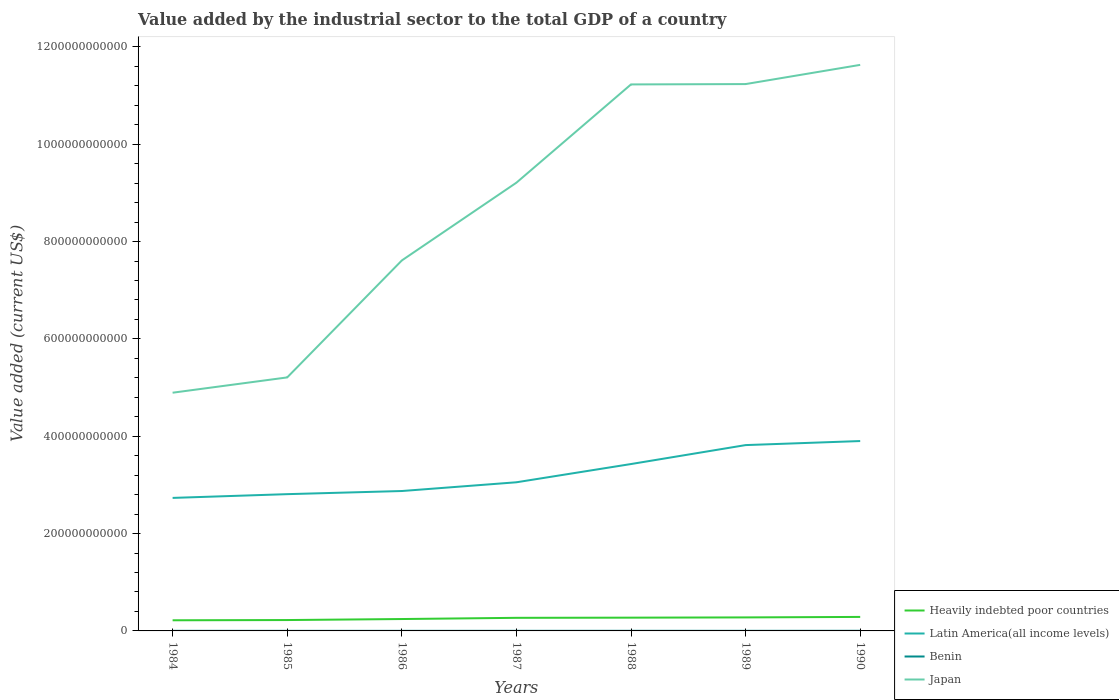Across all years, what is the maximum value added by the industrial sector to the total GDP in Benin?
Make the answer very short. 1.62e+08. What is the total value added by the industrial sector to the total GDP in Latin America(all income levels) in the graph?
Offer a terse response. -3.89e+1. What is the difference between the highest and the second highest value added by the industrial sector to the total GDP in Benin?
Offer a very short reply. 8.23e+07. What is the difference between the highest and the lowest value added by the industrial sector to the total GDP in Benin?
Make the answer very short. 2. Is the value added by the industrial sector to the total GDP in Benin strictly greater than the value added by the industrial sector to the total GDP in Latin America(all income levels) over the years?
Give a very brief answer. Yes. How many years are there in the graph?
Offer a very short reply. 7. What is the difference between two consecutive major ticks on the Y-axis?
Make the answer very short. 2.00e+11. Where does the legend appear in the graph?
Offer a very short reply. Bottom right. How many legend labels are there?
Ensure brevity in your answer.  4. What is the title of the graph?
Ensure brevity in your answer.  Value added by the industrial sector to the total GDP of a country. What is the label or title of the Y-axis?
Provide a succinct answer. Value added (current US$). What is the Value added (current US$) of Heavily indebted poor countries in 1984?
Offer a terse response. 2.19e+1. What is the Value added (current US$) of Latin America(all income levels) in 1984?
Keep it short and to the point. 2.73e+11. What is the Value added (current US$) of Benin in 1984?
Provide a succinct answer. 1.79e+08. What is the Value added (current US$) in Japan in 1984?
Ensure brevity in your answer.  4.89e+11. What is the Value added (current US$) in Heavily indebted poor countries in 1985?
Your answer should be very brief. 2.23e+1. What is the Value added (current US$) in Latin America(all income levels) in 1985?
Keep it short and to the point. 2.81e+11. What is the Value added (current US$) of Benin in 1985?
Keep it short and to the point. 1.75e+08. What is the Value added (current US$) of Japan in 1985?
Make the answer very short. 5.21e+11. What is the Value added (current US$) of Heavily indebted poor countries in 1986?
Ensure brevity in your answer.  2.44e+1. What is the Value added (current US$) in Latin America(all income levels) in 1986?
Provide a short and direct response. 2.87e+11. What is the Value added (current US$) of Benin in 1986?
Your answer should be very brief. 1.62e+08. What is the Value added (current US$) of Japan in 1986?
Offer a very short reply. 7.61e+11. What is the Value added (current US$) in Heavily indebted poor countries in 1987?
Ensure brevity in your answer.  2.69e+1. What is the Value added (current US$) in Latin America(all income levels) in 1987?
Provide a succinct answer. 3.05e+11. What is the Value added (current US$) in Benin in 1987?
Your answer should be compact. 1.93e+08. What is the Value added (current US$) of Japan in 1987?
Offer a very short reply. 9.21e+11. What is the Value added (current US$) in Heavily indebted poor countries in 1988?
Provide a short and direct response. 2.73e+1. What is the Value added (current US$) in Latin America(all income levels) in 1988?
Provide a succinct answer. 3.43e+11. What is the Value added (current US$) in Benin in 1988?
Offer a terse response. 2.17e+08. What is the Value added (current US$) of Japan in 1988?
Provide a short and direct response. 1.12e+12. What is the Value added (current US$) of Heavily indebted poor countries in 1989?
Offer a very short reply. 2.78e+1. What is the Value added (current US$) in Latin America(all income levels) in 1989?
Provide a succinct answer. 3.82e+11. What is the Value added (current US$) in Benin in 1989?
Give a very brief answer. 1.92e+08. What is the Value added (current US$) of Japan in 1989?
Provide a succinct answer. 1.12e+12. What is the Value added (current US$) in Heavily indebted poor countries in 1990?
Your answer should be compact. 2.88e+1. What is the Value added (current US$) in Latin America(all income levels) in 1990?
Give a very brief answer. 3.90e+11. What is the Value added (current US$) of Benin in 1990?
Keep it short and to the point. 2.44e+08. What is the Value added (current US$) of Japan in 1990?
Provide a short and direct response. 1.16e+12. Across all years, what is the maximum Value added (current US$) in Heavily indebted poor countries?
Ensure brevity in your answer.  2.88e+1. Across all years, what is the maximum Value added (current US$) in Latin America(all income levels)?
Make the answer very short. 3.90e+11. Across all years, what is the maximum Value added (current US$) in Benin?
Keep it short and to the point. 2.44e+08. Across all years, what is the maximum Value added (current US$) in Japan?
Ensure brevity in your answer.  1.16e+12. Across all years, what is the minimum Value added (current US$) in Heavily indebted poor countries?
Your answer should be very brief. 2.19e+1. Across all years, what is the minimum Value added (current US$) of Latin America(all income levels)?
Provide a succinct answer. 2.73e+11. Across all years, what is the minimum Value added (current US$) in Benin?
Give a very brief answer. 1.62e+08. Across all years, what is the minimum Value added (current US$) of Japan?
Provide a short and direct response. 4.89e+11. What is the total Value added (current US$) in Heavily indebted poor countries in the graph?
Offer a terse response. 1.79e+11. What is the total Value added (current US$) of Latin America(all income levels) in the graph?
Your response must be concise. 2.26e+12. What is the total Value added (current US$) in Benin in the graph?
Provide a short and direct response. 1.36e+09. What is the total Value added (current US$) in Japan in the graph?
Ensure brevity in your answer.  6.10e+12. What is the difference between the Value added (current US$) in Heavily indebted poor countries in 1984 and that in 1985?
Ensure brevity in your answer.  -4.72e+08. What is the difference between the Value added (current US$) of Latin America(all income levels) in 1984 and that in 1985?
Make the answer very short. -7.70e+09. What is the difference between the Value added (current US$) in Benin in 1984 and that in 1985?
Make the answer very short. 4.76e+06. What is the difference between the Value added (current US$) of Japan in 1984 and that in 1985?
Provide a succinct answer. -3.14e+1. What is the difference between the Value added (current US$) in Heavily indebted poor countries in 1984 and that in 1986?
Provide a short and direct response. -2.55e+09. What is the difference between the Value added (current US$) of Latin America(all income levels) in 1984 and that in 1986?
Keep it short and to the point. -1.41e+1. What is the difference between the Value added (current US$) in Benin in 1984 and that in 1986?
Ensure brevity in your answer.  1.76e+07. What is the difference between the Value added (current US$) of Japan in 1984 and that in 1986?
Offer a very short reply. -2.72e+11. What is the difference between the Value added (current US$) in Heavily indebted poor countries in 1984 and that in 1987?
Give a very brief answer. -5.03e+09. What is the difference between the Value added (current US$) of Latin America(all income levels) in 1984 and that in 1987?
Offer a terse response. -3.21e+1. What is the difference between the Value added (current US$) in Benin in 1984 and that in 1987?
Ensure brevity in your answer.  -1.38e+07. What is the difference between the Value added (current US$) of Japan in 1984 and that in 1987?
Provide a short and direct response. -4.32e+11. What is the difference between the Value added (current US$) of Heavily indebted poor countries in 1984 and that in 1988?
Give a very brief answer. -5.39e+09. What is the difference between the Value added (current US$) of Latin America(all income levels) in 1984 and that in 1988?
Your answer should be compact. -6.96e+1. What is the difference between the Value added (current US$) of Benin in 1984 and that in 1988?
Make the answer very short. -3.76e+07. What is the difference between the Value added (current US$) of Japan in 1984 and that in 1988?
Ensure brevity in your answer.  -6.33e+11. What is the difference between the Value added (current US$) in Heavily indebted poor countries in 1984 and that in 1989?
Provide a succinct answer. -5.90e+09. What is the difference between the Value added (current US$) in Latin America(all income levels) in 1984 and that in 1989?
Give a very brief answer. -1.09e+11. What is the difference between the Value added (current US$) in Benin in 1984 and that in 1989?
Provide a succinct answer. -1.24e+07. What is the difference between the Value added (current US$) in Japan in 1984 and that in 1989?
Your answer should be very brief. -6.34e+11. What is the difference between the Value added (current US$) of Heavily indebted poor countries in 1984 and that in 1990?
Give a very brief answer. -6.90e+09. What is the difference between the Value added (current US$) of Latin America(all income levels) in 1984 and that in 1990?
Ensure brevity in your answer.  -1.17e+11. What is the difference between the Value added (current US$) in Benin in 1984 and that in 1990?
Keep it short and to the point. -6.47e+07. What is the difference between the Value added (current US$) of Japan in 1984 and that in 1990?
Offer a very short reply. -6.74e+11. What is the difference between the Value added (current US$) in Heavily indebted poor countries in 1985 and that in 1986?
Provide a succinct answer. -2.07e+09. What is the difference between the Value added (current US$) of Latin America(all income levels) in 1985 and that in 1986?
Your answer should be compact. -6.44e+09. What is the difference between the Value added (current US$) in Benin in 1985 and that in 1986?
Your response must be concise. 1.29e+07. What is the difference between the Value added (current US$) in Japan in 1985 and that in 1986?
Keep it short and to the point. -2.40e+11. What is the difference between the Value added (current US$) in Heavily indebted poor countries in 1985 and that in 1987?
Give a very brief answer. -4.55e+09. What is the difference between the Value added (current US$) of Latin America(all income levels) in 1985 and that in 1987?
Your answer should be very brief. -2.44e+1. What is the difference between the Value added (current US$) in Benin in 1985 and that in 1987?
Give a very brief answer. -1.85e+07. What is the difference between the Value added (current US$) in Japan in 1985 and that in 1987?
Your answer should be compact. -4.00e+11. What is the difference between the Value added (current US$) of Heavily indebted poor countries in 1985 and that in 1988?
Offer a terse response. -4.91e+09. What is the difference between the Value added (current US$) in Latin America(all income levels) in 1985 and that in 1988?
Your response must be concise. -6.19e+1. What is the difference between the Value added (current US$) of Benin in 1985 and that in 1988?
Make the answer very short. -4.24e+07. What is the difference between the Value added (current US$) of Japan in 1985 and that in 1988?
Provide a short and direct response. -6.02e+11. What is the difference between the Value added (current US$) of Heavily indebted poor countries in 1985 and that in 1989?
Your answer should be compact. -5.43e+09. What is the difference between the Value added (current US$) in Latin America(all income levels) in 1985 and that in 1989?
Your answer should be compact. -1.01e+11. What is the difference between the Value added (current US$) of Benin in 1985 and that in 1989?
Provide a short and direct response. -1.72e+07. What is the difference between the Value added (current US$) in Japan in 1985 and that in 1989?
Your answer should be compact. -6.03e+11. What is the difference between the Value added (current US$) in Heavily indebted poor countries in 1985 and that in 1990?
Provide a short and direct response. -6.43e+09. What is the difference between the Value added (current US$) in Latin America(all income levels) in 1985 and that in 1990?
Give a very brief answer. -1.09e+11. What is the difference between the Value added (current US$) in Benin in 1985 and that in 1990?
Your answer should be very brief. -6.94e+07. What is the difference between the Value added (current US$) in Japan in 1985 and that in 1990?
Keep it short and to the point. -6.42e+11. What is the difference between the Value added (current US$) of Heavily indebted poor countries in 1986 and that in 1987?
Give a very brief answer. -2.48e+09. What is the difference between the Value added (current US$) of Latin America(all income levels) in 1986 and that in 1987?
Ensure brevity in your answer.  -1.80e+1. What is the difference between the Value added (current US$) in Benin in 1986 and that in 1987?
Give a very brief answer. -3.14e+07. What is the difference between the Value added (current US$) in Japan in 1986 and that in 1987?
Offer a very short reply. -1.60e+11. What is the difference between the Value added (current US$) of Heavily indebted poor countries in 1986 and that in 1988?
Provide a short and direct response. -2.84e+09. What is the difference between the Value added (current US$) in Latin America(all income levels) in 1986 and that in 1988?
Give a very brief answer. -5.54e+1. What is the difference between the Value added (current US$) of Benin in 1986 and that in 1988?
Provide a succinct answer. -5.53e+07. What is the difference between the Value added (current US$) in Japan in 1986 and that in 1988?
Keep it short and to the point. -3.62e+11. What is the difference between the Value added (current US$) of Heavily indebted poor countries in 1986 and that in 1989?
Offer a terse response. -3.35e+09. What is the difference between the Value added (current US$) in Latin America(all income levels) in 1986 and that in 1989?
Your answer should be compact. -9.44e+1. What is the difference between the Value added (current US$) of Benin in 1986 and that in 1989?
Keep it short and to the point. -3.00e+07. What is the difference between the Value added (current US$) of Japan in 1986 and that in 1989?
Keep it short and to the point. -3.62e+11. What is the difference between the Value added (current US$) in Heavily indebted poor countries in 1986 and that in 1990?
Your answer should be very brief. -4.36e+09. What is the difference between the Value added (current US$) of Latin America(all income levels) in 1986 and that in 1990?
Your answer should be very brief. -1.03e+11. What is the difference between the Value added (current US$) of Benin in 1986 and that in 1990?
Provide a succinct answer. -8.23e+07. What is the difference between the Value added (current US$) in Japan in 1986 and that in 1990?
Give a very brief answer. -4.02e+11. What is the difference between the Value added (current US$) in Heavily indebted poor countries in 1987 and that in 1988?
Provide a succinct answer. -3.60e+08. What is the difference between the Value added (current US$) in Latin America(all income levels) in 1987 and that in 1988?
Offer a terse response. -3.75e+1. What is the difference between the Value added (current US$) of Benin in 1987 and that in 1988?
Your response must be concise. -2.38e+07. What is the difference between the Value added (current US$) of Japan in 1987 and that in 1988?
Your response must be concise. -2.02e+11. What is the difference between the Value added (current US$) in Heavily indebted poor countries in 1987 and that in 1989?
Ensure brevity in your answer.  -8.71e+08. What is the difference between the Value added (current US$) of Latin America(all income levels) in 1987 and that in 1989?
Provide a succinct answer. -7.64e+1. What is the difference between the Value added (current US$) in Benin in 1987 and that in 1989?
Your response must be concise. 1.39e+06. What is the difference between the Value added (current US$) in Japan in 1987 and that in 1989?
Your answer should be compact. -2.03e+11. What is the difference between the Value added (current US$) of Heavily indebted poor countries in 1987 and that in 1990?
Give a very brief answer. -1.88e+09. What is the difference between the Value added (current US$) of Latin America(all income levels) in 1987 and that in 1990?
Your answer should be compact. -8.47e+1. What is the difference between the Value added (current US$) of Benin in 1987 and that in 1990?
Provide a short and direct response. -5.09e+07. What is the difference between the Value added (current US$) of Japan in 1987 and that in 1990?
Provide a succinct answer. -2.42e+11. What is the difference between the Value added (current US$) of Heavily indebted poor countries in 1988 and that in 1989?
Your answer should be very brief. -5.11e+08. What is the difference between the Value added (current US$) of Latin America(all income levels) in 1988 and that in 1989?
Provide a succinct answer. -3.89e+1. What is the difference between the Value added (current US$) of Benin in 1988 and that in 1989?
Offer a terse response. 2.52e+07. What is the difference between the Value added (current US$) of Japan in 1988 and that in 1989?
Your answer should be very brief. -6.85e+08. What is the difference between the Value added (current US$) of Heavily indebted poor countries in 1988 and that in 1990?
Your answer should be compact. -1.52e+09. What is the difference between the Value added (current US$) of Latin America(all income levels) in 1988 and that in 1990?
Keep it short and to the point. -4.73e+1. What is the difference between the Value added (current US$) of Benin in 1988 and that in 1990?
Ensure brevity in your answer.  -2.71e+07. What is the difference between the Value added (current US$) of Japan in 1988 and that in 1990?
Provide a succinct answer. -4.02e+1. What is the difference between the Value added (current US$) in Heavily indebted poor countries in 1989 and that in 1990?
Your answer should be compact. -1.01e+09. What is the difference between the Value added (current US$) of Latin America(all income levels) in 1989 and that in 1990?
Make the answer very short. -8.32e+09. What is the difference between the Value added (current US$) of Benin in 1989 and that in 1990?
Give a very brief answer. -5.23e+07. What is the difference between the Value added (current US$) of Japan in 1989 and that in 1990?
Offer a terse response. -3.95e+1. What is the difference between the Value added (current US$) in Heavily indebted poor countries in 1984 and the Value added (current US$) in Latin America(all income levels) in 1985?
Keep it short and to the point. -2.59e+11. What is the difference between the Value added (current US$) in Heavily indebted poor countries in 1984 and the Value added (current US$) in Benin in 1985?
Your answer should be very brief. 2.17e+1. What is the difference between the Value added (current US$) in Heavily indebted poor countries in 1984 and the Value added (current US$) in Japan in 1985?
Offer a terse response. -4.99e+11. What is the difference between the Value added (current US$) in Latin America(all income levels) in 1984 and the Value added (current US$) in Benin in 1985?
Give a very brief answer. 2.73e+11. What is the difference between the Value added (current US$) of Latin America(all income levels) in 1984 and the Value added (current US$) of Japan in 1985?
Provide a succinct answer. -2.48e+11. What is the difference between the Value added (current US$) of Benin in 1984 and the Value added (current US$) of Japan in 1985?
Your answer should be compact. -5.21e+11. What is the difference between the Value added (current US$) in Heavily indebted poor countries in 1984 and the Value added (current US$) in Latin America(all income levels) in 1986?
Offer a terse response. -2.66e+11. What is the difference between the Value added (current US$) in Heavily indebted poor countries in 1984 and the Value added (current US$) in Benin in 1986?
Your response must be concise. 2.17e+1. What is the difference between the Value added (current US$) in Heavily indebted poor countries in 1984 and the Value added (current US$) in Japan in 1986?
Provide a short and direct response. -7.39e+11. What is the difference between the Value added (current US$) in Latin America(all income levels) in 1984 and the Value added (current US$) in Benin in 1986?
Give a very brief answer. 2.73e+11. What is the difference between the Value added (current US$) of Latin America(all income levels) in 1984 and the Value added (current US$) of Japan in 1986?
Provide a succinct answer. -4.88e+11. What is the difference between the Value added (current US$) in Benin in 1984 and the Value added (current US$) in Japan in 1986?
Offer a very short reply. -7.61e+11. What is the difference between the Value added (current US$) of Heavily indebted poor countries in 1984 and the Value added (current US$) of Latin America(all income levels) in 1987?
Offer a very short reply. -2.84e+11. What is the difference between the Value added (current US$) in Heavily indebted poor countries in 1984 and the Value added (current US$) in Benin in 1987?
Your answer should be compact. 2.17e+1. What is the difference between the Value added (current US$) in Heavily indebted poor countries in 1984 and the Value added (current US$) in Japan in 1987?
Offer a terse response. -8.99e+11. What is the difference between the Value added (current US$) in Latin America(all income levels) in 1984 and the Value added (current US$) in Benin in 1987?
Provide a short and direct response. 2.73e+11. What is the difference between the Value added (current US$) of Latin America(all income levels) in 1984 and the Value added (current US$) of Japan in 1987?
Make the answer very short. -6.48e+11. What is the difference between the Value added (current US$) in Benin in 1984 and the Value added (current US$) in Japan in 1987?
Your response must be concise. -9.21e+11. What is the difference between the Value added (current US$) in Heavily indebted poor countries in 1984 and the Value added (current US$) in Latin America(all income levels) in 1988?
Provide a succinct answer. -3.21e+11. What is the difference between the Value added (current US$) in Heavily indebted poor countries in 1984 and the Value added (current US$) in Benin in 1988?
Your response must be concise. 2.17e+1. What is the difference between the Value added (current US$) in Heavily indebted poor countries in 1984 and the Value added (current US$) in Japan in 1988?
Keep it short and to the point. -1.10e+12. What is the difference between the Value added (current US$) of Latin America(all income levels) in 1984 and the Value added (current US$) of Benin in 1988?
Ensure brevity in your answer.  2.73e+11. What is the difference between the Value added (current US$) of Latin America(all income levels) in 1984 and the Value added (current US$) of Japan in 1988?
Your response must be concise. -8.50e+11. What is the difference between the Value added (current US$) of Benin in 1984 and the Value added (current US$) of Japan in 1988?
Your response must be concise. -1.12e+12. What is the difference between the Value added (current US$) in Heavily indebted poor countries in 1984 and the Value added (current US$) in Latin America(all income levels) in 1989?
Offer a terse response. -3.60e+11. What is the difference between the Value added (current US$) of Heavily indebted poor countries in 1984 and the Value added (current US$) of Benin in 1989?
Ensure brevity in your answer.  2.17e+1. What is the difference between the Value added (current US$) of Heavily indebted poor countries in 1984 and the Value added (current US$) of Japan in 1989?
Your answer should be very brief. -1.10e+12. What is the difference between the Value added (current US$) of Latin America(all income levels) in 1984 and the Value added (current US$) of Benin in 1989?
Keep it short and to the point. 2.73e+11. What is the difference between the Value added (current US$) in Latin America(all income levels) in 1984 and the Value added (current US$) in Japan in 1989?
Your answer should be compact. -8.50e+11. What is the difference between the Value added (current US$) in Benin in 1984 and the Value added (current US$) in Japan in 1989?
Make the answer very short. -1.12e+12. What is the difference between the Value added (current US$) in Heavily indebted poor countries in 1984 and the Value added (current US$) in Latin America(all income levels) in 1990?
Ensure brevity in your answer.  -3.68e+11. What is the difference between the Value added (current US$) of Heavily indebted poor countries in 1984 and the Value added (current US$) of Benin in 1990?
Your response must be concise. 2.16e+1. What is the difference between the Value added (current US$) of Heavily indebted poor countries in 1984 and the Value added (current US$) of Japan in 1990?
Provide a short and direct response. -1.14e+12. What is the difference between the Value added (current US$) of Latin America(all income levels) in 1984 and the Value added (current US$) of Benin in 1990?
Your answer should be compact. 2.73e+11. What is the difference between the Value added (current US$) of Latin America(all income levels) in 1984 and the Value added (current US$) of Japan in 1990?
Provide a short and direct response. -8.90e+11. What is the difference between the Value added (current US$) of Benin in 1984 and the Value added (current US$) of Japan in 1990?
Offer a very short reply. -1.16e+12. What is the difference between the Value added (current US$) of Heavily indebted poor countries in 1985 and the Value added (current US$) of Latin America(all income levels) in 1986?
Your answer should be compact. -2.65e+11. What is the difference between the Value added (current US$) of Heavily indebted poor countries in 1985 and the Value added (current US$) of Benin in 1986?
Offer a terse response. 2.22e+1. What is the difference between the Value added (current US$) of Heavily indebted poor countries in 1985 and the Value added (current US$) of Japan in 1986?
Give a very brief answer. -7.39e+11. What is the difference between the Value added (current US$) of Latin America(all income levels) in 1985 and the Value added (current US$) of Benin in 1986?
Offer a terse response. 2.81e+11. What is the difference between the Value added (current US$) of Latin America(all income levels) in 1985 and the Value added (current US$) of Japan in 1986?
Your answer should be compact. -4.80e+11. What is the difference between the Value added (current US$) in Benin in 1985 and the Value added (current US$) in Japan in 1986?
Provide a short and direct response. -7.61e+11. What is the difference between the Value added (current US$) of Heavily indebted poor countries in 1985 and the Value added (current US$) of Latin America(all income levels) in 1987?
Make the answer very short. -2.83e+11. What is the difference between the Value added (current US$) in Heavily indebted poor countries in 1985 and the Value added (current US$) in Benin in 1987?
Provide a succinct answer. 2.22e+1. What is the difference between the Value added (current US$) of Heavily indebted poor countries in 1985 and the Value added (current US$) of Japan in 1987?
Your response must be concise. -8.99e+11. What is the difference between the Value added (current US$) of Latin America(all income levels) in 1985 and the Value added (current US$) of Benin in 1987?
Your answer should be compact. 2.81e+11. What is the difference between the Value added (current US$) in Latin America(all income levels) in 1985 and the Value added (current US$) in Japan in 1987?
Keep it short and to the point. -6.40e+11. What is the difference between the Value added (current US$) in Benin in 1985 and the Value added (current US$) in Japan in 1987?
Offer a very short reply. -9.21e+11. What is the difference between the Value added (current US$) of Heavily indebted poor countries in 1985 and the Value added (current US$) of Latin America(all income levels) in 1988?
Ensure brevity in your answer.  -3.21e+11. What is the difference between the Value added (current US$) of Heavily indebted poor countries in 1985 and the Value added (current US$) of Benin in 1988?
Keep it short and to the point. 2.21e+1. What is the difference between the Value added (current US$) of Heavily indebted poor countries in 1985 and the Value added (current US$) of Japan in 1988?
Provide a short and direct response. -1.10e+12. What is the difference between the Value added (current US$) in Latin America(all income levels) in 1985 and the Value added (current US$) in Benin in 1988?
Provide a short and direct response. 2.81e+11. What is the difference between the Value added (current US$) in Latin America(all income levels) in 1985 and the Value added (current US$) in Japan in 1988?
Provide a short and direct response. -8.42e+11. What is the difference between the Value added (current US$) of Benin in 1985 and the Value added (current US$) of Japan in 1988?
Your answer should be compact. -1.12e+12. What is the difference between the Value added (current US$) of Heavily indebted poor countries in 1985 and the Value added (current US$) of Latin America(all income levels) in 1989?
Give a very brief answer. -3.59e+11. What is the difference between the Value added (current US$) of Heavily indebted poor countries in 1985 and the Value added (current US$) of Benin in 1989?
Make the answer very short. 2.22e+1. What is the difference between the Value added (current US$) in Heavily indebted poor countries in 1985 and the Value added (current US$) in Japan in 1989?
Ensure brevity in your answer.  -1.10e+12. What is the difference between the Value added (current US$) in Latin America(all income levels) in 1985 and the Value added (current US$) in Benin in 1989?
Keep it short and to the point. 2.81e+11. What is the difference between the Value added (current US$) of Latin America(all income levels) in 1985 and the Value added (current US$) of Japan in 1989?
Make the answer very short. -8.43e+11. What is the difference between the Value added (current US$) in Benin in 1985 and the Value added (current US$) in Japan in 1989?
Provide a succinct answer. -1.12e+12. What is the difference between the Value added (current US$) in Heavily indebted poor countries in 1985 and the Value added (current US$) in Latin America(all income levels) in 1990?
Provide a succinct answer. -3.68e+11. What is the difference between the Value added (current US$) of Heavily indebted poor countries in 1985 and the Value added (current US$) of Benin in 1990?
Keep it short and to the point. 2.21e+1. What is the difference between the Value added (current US$) of Heavily indebted poor countries in 1985 and the Value added (current US$) of Japan in 1990?
Keep it short and to the point. -1.14e+12. What is the difference between the Value added (current US$) of Latin America(all income levels) in 1985 and the Value added (current US$) of Benin in 1990?
Provide a short and direct response. 2.81e+11. What is the difference between the Value added (current US$) of Latin America(all income levels) in 1985 and the Value added (current US$) of Japan in 1990?
Your answer should be compact. -8.82e+11. What is the difference between the Value added (current US$) of Benin in 1985 and the Value added (current US$) of Japan in 1990?
Your response must be concise. -1.16e+12. What is the difference between the Value added (current US$) of Heavily indebted poor countries in 1986 and the Value added (current US$) of Latin America(all income levels) in 1987?
Give a very brief answer. -2.81e+11. What is the difference between the Value added (current US$) of Heavily indebted poor countries in 1986 and the Value added (current US$) of Benin in 1987?
Your answer should be compact. 2.42e+1. What is the difference between the Value added (current US$) of Heavily indebted poor countries in 1986 and the Value added (current US$) of Japan in 1987?
Provide a succinct answer. -8.97e+11. What is the difference between the Value added (current US$) of Latin America(all income levels) in 1986 and the Value added (current US$) of Benin in 1987?
Make the answer very short. 2.87e+11. What is the difference between the Value added (current US$) in Latin America(all income levels) in 1986 and the Value added (current US$) in Japan in 1987?
Your answer should be very brief. -6.34e+11. What is the difference between the Value added (current US$) in Benin in 1986 and the Value added (current US$) in Japan in 1987?
Offer a very short reply. -9.21e+11. What is the difference between the Value added (current US$) in Heavily indebted poor countries in 1986 and the Value added (current US$) in Latin America(all income levels) in 1988?
Keep it short and to the point. -3.18e+11. What is the difference between the Value added (current US$) in Heavily indebted poor countries in 1986 and the Value added (current US$) in Benin in 1988?
Your response must be concise. 2.42e+1. What is the difference between the Value added (current US$) of Heavily indebted poor countries in 1986 and the Value added (current US$) of Japan in 1988?
Keep it short and to the point. -1.10e+12. What is the difference between the Value added (current US$) in Latin America(all income levels) in 1986 and the Value added (current US$) in Benin in 1988?
Provide a short and direct response. 2.87e+11. What is the difference between the Value added (current US$) in Latin America(all income levels) in 1986 and the Value added (current US$) in Japan in 1988?
Offer a terse response. -8.35e+11. What is the difference between the Value added (current US$) in Benin in 1986 and the Value added (current US$) in Japan in 1988?
Make the answer very short. -1.12e+12. What is the difference between the Value added (current US$) of Heavily indebted poor countries in 1986 and the Value added (current US$) of Latin America(all income levels) in 1989?
Offer a terse response. -3.57e+11. What is the difference between the Value added (current US$) in Heavily indebted poor countries in 1986 and the Value added (current US$) in Benin in 1989?
Make the answer very short. 2.42e+1. What is the difference between the Value added (current US$) in Heavily indebted poor countries in 1986 and the Value added (current US$) in Japan in 1989?
Ensure brevity in your answer.  -1.10e+12. What is the difference between the Value added (current US$) of Latin America(all income levels) in 1986 and the Value added (current US$) of Benin in 1989?
Offer a terse response. 2.87e+11. What is the difference between the Value added (current US$) of Latin America(all income levels) in 1986 and the Value added (current US$) of Japan in 1989?
Keep it short and to the point. -8.36e+11. What is the difference between the Value added (current US$) in Benin in 1986 and the Value added (current US$) in Japan in 1989?
Your answer should be very brief. -1.12e+12. What is the difference between the Value added (current US$) in Heavily indebted poor countries in 1986 and the Value added (current US$) in Latin America(all income levels) in 1990?
Your answer should be compact. -3.66e+11. What is the difference between the Value added (current US$) in Heavily indebted poor countries in 1986 and the Value added (current US$) in Benin in 1990?
Give a very brief answer. 2.42e+1. What is the difference between the Value added (current US$) of Heavily indebted poor countries in 1986 and the Value added (current US$) of Japan in 1990?
Keep it short and to the point. -1.14e+12. What is the difference between the Value added (current US$) of Latin America(all income levels) in 1986 and the Value added (current US$) of Benin in 1990?
Make the answer very short. 2.87e+11. What is the difference between the Value added (current US$) in Latin America(all income levels) in 1986 and the Value added (current US$) in Japan in 1990?
Offer a terse response. -8.76e+11. What is the difference between the Value added (current US$) in Benin in 1986 and the Value added (current US$) in Japan in 1990?
Make the answer very short. -1.16e+12. What is the difference between the Value added (current US$) of Heavily indebted poor countries in 1987 and the Value added (current US$) of Latin America(all income levels) in 1988?
Ensure brevity in your answer.  -3.16e+11. What is the difference between the Value added (current US$) of Heavily indebted poor countries in 1987 and the Value added (current US$) of Benin in 1988?
Offer a terse response. 2.67e+1. What is the difference between the Value added (current US$) in Heavily indebted poor countries in 1987 and the Value added (current US$) in Japan in 1988?
Your response must be concise. -1.10e+12. What is the difference between the Value added (current US$) of Latin America(all income levels) in 1987 and the Value added (current US$) of Benin in 1988?
Give a very brief answer. 3.05e+11. What is the difference between the Value added (current US$) in Latin America(all income levels) in 1987 and the Value added (current US$) in Japan in 1988?
Offer a terse response. -8.17e+11. What is the difference between the Value added (current US$) of Benin in 1987 and the Value added (current US$) of Japan in 1988?
Offer a terse response. -1.12e+12. What is the difference between the Value added (current US$) of Heavily indebted poor countries in 1987 and the Value added (current US$) of Latin America(all income levels) in 1989?
Make the answer very short. -3.55e+11. What is the difference between the Value added (current US$) in Heavily indebted poor countries in 1987 and the Value added (current US$) in Benin in 1989?
Your answer should be compact. 2.67e+1. What is the difference between the Value added (current US$) of Heavily indebted poor countries in 1987 and the Value added (current US$) of Japan in 1989?
Provide a short and direct response. -1.10e+12. What is the difference between the Value added (current US$) in Latin America(all income levels) in 1987 and the Value added (current US$) in Benin in 1989?
Provide a short and direct response. 3.05e+11. What is the difference between the Value added (current US$) of Latin America(all income levels) in 1987 and the Value added (current US$) of Japan in 1989?
Provide a short and direct response. -8.18e+11. What is the difference between the Value added (current US$) of Benin in 1987 and the Value added (current US$) of Japan in 1989?
Provide a short and direct response. -1.12e+12. What is the difference between the Value added (current US$) of Heavily indebted poor countries in 1987 and the Value added (current US$) of Latin America(all income levels) in 1990?
Keep it short and to the point. -3.63e+11. What is the difference between the Value added (current US$) in Heavily indebted poor countries in 1987 and the Value added (current US$) in Benin in 1990?
Your answer should be very brief. 2.67e+1. What is the difference between the Value added (current US$) in Heavily indebted poor countries in 1987 and the Value added (current US$) in Japan in 1990?
Keep it short and to the point. -1.14e+12. What is the difference between the Value added (current US$) of Latin America(all income levels) in 1987 and the Value added (current US$) of Benin in 1990?
Offer a very short reply. 3.05e+11. What is the difference between the Value added (current US$) in Latin America(all income levels) in 1987 and the Value added (current US$) in Japan in 1990?
Offer a terse response. -8.58e+11. What is the difference between the Value added (current US$) in Benin in 1987 and the Value added (current US$) in Japan in 1990?
Make the answer very short. -1.16e+12. What is the difference between the Value added (current US$) of Heavily indebted poor countries in 1988 and the Value added (current US$) of Latin America(all income levels) in 1989?
Ensure brevity in your answer.  -3.55e+11. What is the difference between the Value added (current US$) in Heavily indebted poor countries in 1988 and the Value added (current US$) in Benin in 1989?
Offer a very short reply. 2.71e+1. What is the difference between the Value added (current US$) of Heavily indebted poor countries in 1988 and the Value added (current US$) of Japan in 1989?
Give a very brief answer. -1.10e+12. What is the difference between the Value added (current US$) in Latin America(all income levels) in 1988 and the Value added (current US$) in Benin in 1989?
Provide a succinct answer. 3.43e+11. What is the difference between the Value added (current US$) in Latin America(all income levels) in 1988 and the Value added (current US$) in Japan in 1989?
Offer a very short reply. -7.81e+11. What is the difference between the Value added (current US$) in Benin in 1988 and the Value added (current US$) in Japan in 1989?
Ensure brevity in your answer.  -1.12e+12. What is the difference between the Value added (current US$) in Heavily indebted poor countries in 1988 and the Value added (current US$) in Latin America(all income levels) in 1990?
Provide a succinct answer. -3.63e+11. What is the difference between the Value added (current US$) in Heavily indebted poor countries in 1988 and the Value added (current US$) in Benin in 1990?
Make the answer very short. 2.70e+1. What is the difference between the Value added (current US$) of Heavily indebted poor countries in 1988 and the Value added (current US$) of Japan in 1990?
Offer a very short reply. -1.14e+12. What is the difference between the Value added (current US$) of Latin America(all income levels) in 1988 and the Value added (current US$) of Benin in 1990?
Ensure brevity in your answer.  3.43e+11. What is the difference between the Value added (current US$) of Latin America(all income levels) in 1988 and the Value added (current US$) of Japan in 1990?
Your response must be concise. -8.20e+11. What is the difference between the Value added (current US$) of Benin in 1988 and the Value added (current US$) of Japan in 1990?
Make the answer very short. -1.16e+12. What is the difference between the Value added (current US$) in Heavily indebted poor countries in 1989 and the Value added (current US$) in Latin America(all income levels) in 1990?
Ensure brevity in your answer.  -3.62e+11. What is the difference between the Value added (current US$) in Heavily indebted poor countries in 1989 and the Value added (current US$) in Benin in 1990?
Give a very brief answer. 2.75e+1. What is the difference between the Value added (current US$) of Heavily indebted poor countries in 1989 and the Value added (current US$) of Japan in 1990?
Keep it short and to the point. -1.14e+12. What is the difference between the Value added (current US$) of Latin America(all income levels) in 1989 and the Value added (current US$) of Benin in 1990?
Provide a short and direct response. 3.82e+11. What is the difference between the Value added (current US$) in Latin America(all income levels) in 1989 and the Value added (current US$) in Japan in 1990?
Ensure brevity in your answer.  -7.81e+11. What is the difference between the Value added (current US$) of Benin in 1989 and the Value added (current US$) of Japan in 1990?
Provide a short and direct response. -1.16e+12. What is the average Value added (current US$) of Heavily indebted poor countries per year?
Offer a very short reply. 2.56e+1. What is the average Value added (current US$) in Latin America(all income levels) per year?
Offer a terse response. 3.23e+11. What is the average Value added (current US$) of Benin per year?
Keep it short and to the point. 1.95e+08. What is the average Value added (current US$) of Japan per year?
Ensure brevity in your answer.  8.72e+11. In the year 1984, what is the difference between the Value added (current US$) in Heavily indebted poor countries and Value added (current US$) in Latin America(all income levels)?
Offer a terse response. -2.51e+11. In the year 1984, what is the difference between the Value added (current US$) of Heavily indebted poor countries and Value added (current US$) of Benin?
Keep it short and to the point. 2.17e+1. In the year 1984, what is the difference between the Value added (current US$) in Heavily indebted poor countries and Value added (current US$) in Japan?
Offer a very short reply. -4.68e+11. In the year 1984, what is the difference between the Value added (current US$) of Latin America(all income levels) and Value added (current US$) of Benin?
Ensure brevity in your answer.  2.73e+11. In the year 1984, what is the difference between the Value added (current US$) in Latin America(all income levels) and Value added (current US$) in Japan?
Keep it short and to the point. -2.16e+11. In the year 1984, what is the difference between the Value added (current US$) of Benin and Value added (current US$) of Japan?
Offer a terse response. -4.89e+11. In the year 1985, what is the difference between the Value added (current US$) in Heavily indebted poor countries and Value added (current US$) in Latin America(all income levels)?
Your response must be concise. -2.59e+11. In the year 1985, what is the difference between the Value added (current US$) in Heavily indebted poor countries and Value added (current US$) in Benin?
Provide a succinct answer. 2.22e+1. In the year 1985, what is the difference between the Value added (current US$) in Heavily indebted poor countries and Value added (current US$) in Japan?
Your response must be concise. -4.99e+11. In the year 1985, what is the difference between the Value added (current US$) in Latin America(all income levels) and Value added (current US$) in Benin?
Offer a terse response. 2.81e+11. In the year 1985, what is the difference between the Value added (current US$) in Latin America(all income levels) and Value added (current US$) in Japan?
Provide a short and direct response. -2.40e+11. In the year 1985, what is the difference between the Value added (current US$) in Benin and Value added (current US$) in Japan?
Your response must be concise. -5.21e+11. In the year 1986, what is the difference between the Value added (current US$) of Heavily indebted poor countries and Value added (current US$) of Latin America(all income levels)?
Offer a terse response. -2.63e+11. In the year 1986, what is the difference between the Value added (current US$) in Heavily indebted poor countries and Value added (current US$) in Benin?
Give a very brief answer. 2.43e+1. In the year 1986, what is the difference between the Value added (current US$) in Heavily indebted poor countries and Value added (current US$) in Japan?
Provide a short and direct response. -7.37e+11. In the year 1986, what is the difference between the Value added (current US$) in Latin America(all income levels) and Value added (current US$) in Benin?
Make the answer very short. 2.87e+11. In the year 1986, what is the difference between the Value added (current US$) of Latin America(all income levels) and Value added (current US$) of Japan?
Make the answer very short. -4.74e+11. In the year 1986, what is the difference between the Value added (current US$) in Benin and Value added (current US$) in Japan?
Make the answer very short. -7.61e+11. In the year 1987, what is the difference between the Value added (current US$) of Heavily indebted poor countries and Value added (current US$) of Latin America(all income levels)?
Give a very brief answer. -2.79e+11. In the year 1987, what is the difference between the Value added (current US$) in Heavily indebted poor countries and Value added (current US$) in Benin?
Your response must be concise. 2.67e+1. In the year 1987, what is the difference between the Value added (current US$) of Heavily indebted poor countries and Value added (current US$) of Japan?
Keep it short and to the point. -8.94e+11. In the year 1987, what is the difference between the Value added (current US$) in Latin America(all income levels) and Value added (current US$) in Benin?
Your answer should be very brief. 3.05e+11. In the year 1987, what is the difference between the Value added (current US$) of Latin America(all income levels) and Value added (current US$) of Japan?
Provide a succinct answer. -6.16e+11. In the year 1987, what is the difference between the Value added (current US$) in Benin and Value added (current US$) in Japan?
Keep it short and to the point. -9.21e+11. In the year 1988, what is the difference between the Value added (current US$) in Heavily indebted poor countries and Value added (current US$) in Latin America(all income levels)?
Provide a short and direct response. -3.16e+11. In the year 1988, what is the difference between the Value added (current US$) in Heavily indebted poor countries and Value added (current US$) in Benin?
Give a very brief answer. 2.70e+1. In the year 1988, what is the difference between the Value added (current US$) in Heavily indebted poor countries and Value added (current US$) in Japan?
Provide a short and direct response. -1.10e+12. In the year 1988, what is the difference between the Value added (current US$) in Latin America(all income levels) and Value added (current US$) in Benin?
Provide a succinct answer. 3.43e+11. In the year 1988, what is the difference between the Value added (current US$) in Latin America(all income levels) and Value added (current US$) in Japan?
Ensure brevity in your answer.  -7.80e+11. In the year 1988, what is the difference between the Value added (current US$) of Benin and Value added (current US$) of Japan?
Offer a terse response. -1.12e+12. In the year 1989, what is the difference between the Value added (current US$) of Heavily indebted poor countries and Value added (current US$) of Latin America(all income levels)?
Provide a succinct answer. -3.54e+11. In the year 1989, what is the difference between the Value added (current US$) in Heavily indebted poor countries and Value added (current US$) in Benin?
Ensure brevity in your answer.  2.76e+1. In the year 1989, what is the difference between the Value added (current US$) of Heavily indebted poor countries and Value added (current US$) of Japan?
Keep it short and to the point. -1.10e+12. In the year 1989, what is the difference between the Value added (current US$) in Latin America(all income levels) and Value added (current US$) in Benin?
Make the answer very short. 3.82e+11. In the year 1989, what is the difference between the Value added (current US$) in Latin America(all income levels) and Value added (current US$) in Japan?
Your response must be concise. -7.42e+11. In the year 1989, what is the difference between the Value added (current US$) of Benin and Value added (current US$) of Japan?
Your answer should be compact. -1.12e+12. In the year 1990, what is the difference between the Value added (current US$) of Heavily indebted poor countries and Value added (current US$) of Latin America(all income levels)?
Keep it short and to the point. -3.61e+11. In the year 1990, what is the difference between the Value added (current US$) of Heavily indebted poor countries and Value added (current US$) of Benin?
Offer a very short reply. 2.85e+1. In the year 1990, what is the difference between the Value added (current US$) in Heavily indebted poor countries and Value added (current US$) in Japan?
Your answer should be compact. -1.13e+12. In the year 1990, what is the difference between the Value added (current US$) in Latin America(all income levels) and Value added (current US$) in Benin?
Ensure brevity in your answer.  3.90e+11. In the year 1990, what is the difference between the Value added (current US$) in Latin America(all income levels) and Value added (current US$) in Japan?
Your answer should be very brief. -7.73e+11. In the year 1990, what is the difference between the Value added (current US$) of Benin and Value added (current US$) of Japan?
Your response must be concise. -1.16e+12. What is the ratio of the Value added (current US$) of Heavily indebted poor countries in 1984 to that in 1985?
Provide a short and direct response. 0.98. What is the ratio of the Value added (current US$) of Latin America(all income levels) in 1984 to that in 1985?
Provide a succinct answer. 0.97. What is the ratio of the Value added (current US$) in Benin in 1984 to that in 1985?
Keep it short and to the point. 1.03. What is the ratio of the Value added (current US$) in Japan in 1984 to that in 1985?
Ensure brevity in your answer.  0.94. What is the ratio of the Value added (current US$) of Heavily indebted poor countries in 1984 to that in 1986?
Provide a short and direct response. 0.9. What is the ratio of the Value added (current US$) of Latin America(all income levels) in 1984 to that in 1986?
Your response must be concise. 0.95. What is the ratio of the Value added (current US$) of Benin in 1984 to that in 1986?
Give a very brief answer. 1.11. What is the ratio of the Value added (current US$) of Japan in 1984 to that in 1986?
Your answer should be very brief. 0.64. What is the ratio of the Value added (current US$) of Heavily indebted poor countries in 1984 to that in 1987?
Provide a succinct answer. 0.81. What is the ratio of the Value added (current US$) in Latin America(all income levels) in 1984 to that in 1987?
Your answer should be very brief. 0.89. What is the ratio of the Value added (current US$) in Benin in 1984 to that in 1987?
Give a very brief answer. 0.93. What is the ratio of the Value added (current US$) of Japan in 1984 to that in 1987?
Make the answer very short. 0.53. What is the ratio of the Value added (current US$) of Heavily indebted poor countries in 1984 to that in 1988?
Keep it short and to the point. 0.8. What is the ratio of the Value added (current US$) in Latin America(all income levels) in 1984 to that in 1988?
Your answer should be very brief. 0.8. What is the ratio of the Value added (current US$) in Benin in 1984 to that in 1988?
Make the answer very short. 0.83. What is the ratio of the Value added (current US$) in Japan in 1984 to that in 1988?
Give a very brief answer. 0.44. What is the ratio of the Value added (current US$) of Heavily indebted poor countries in 1984 to that in 1989?
Give a very brief answer. 0.79. What is the ratio of the Value added (current US$) of Latin America(all income levels) in 1984 to that in 1989?
Your answer should be very brief. 0.72. What is the ratio of the Value added (current US$) of Benin in 1984 to that in 1989?
Your response must be concise. 0.94. What is the ratio of the Value added (current US$) of Japan in 1984 to that in 1989?
Provide a short and direct response. 0.44. What is the ratio of the Value added (current US$) of Heavily indebted poor countries in 1984 to that in 1990?
Ensure brevity in your answer.  0.76. What is the ratio of the Value added (current US$) in Latin America(all income levels) in 1984 to that in 1990?
Your answer should be very brief. 0.7. What is the ratio of the Value added (current US$) of Benin in 1984 to that in 1990?
Keep it short and to the point. 0.74. What is the ratio of the Value added (current US$) in Japan in 1984 to that in 1990?
Give a very brief answer. 0.42. What is the ratio of the Value added (current US$) in Heavily indebted poor countries in 1985 to that in 1986?
Offer a terse response. 0.92. What is the ratio of the Value added (current US$) in Latin America(all income levels) in 1985 to that in 1986?
Offer a very short reply. 0.98. What is the ratio of the Value added (current US$) of Benin in 1985 to that in 1986?
Provide a succinct answer. 1.08. What is the ratio of the Value added (current US$) of Japan in 1985 to that in 1986?
Your response must be concise. 0.68. What is the ratio of the Value added (current US$) in Heavily indebted poor countries in 1985 to that in 1987?
Your response must be concise. 0.83. What is the ratio of the Value added (current US$) of Latin America(all income levels) in 1985 to that in 1987?
Provide a short and direct response. 0.92. What is the ratio of the Value added (current US$) in Benin in 1985 to that in 1987?
Your answer should be very brief. 0.9. What is the ratio of the Value added (current US$) of Japan in 1985 to that in 1987?
Make the answer very short. 0.57. What is the ratio of the Value added (current US$) in Heavily indebted poor countries in 1985 to that in 1988?
Provide a succinct answer. 0.82. What is the ratio of the Value added (current US$) in Latin America(all income levels) in 1985 to that in 1988?
Give a very brief answer. 0.82. What is the ratio of the Value added (current US$) of Benin in 1985 to that in 1988?
Offer a terse response. 0.8. What is the ratio of the Value added (current US$) of Japan in 1985 to that in 1988?
Make the answer very short. 0.46. What is the ratio of the Value added (current US$) of Heavily indebted poor countries in 1985 to that in 1989?
Provide a short and direct response. 0.8. What is the ratio of the Value added (current US$) of Latin America(all income levels) in 1985 to that in 1989?
Keep it short and to the point. 0.74. What is the ratio of the Value added (current US$) of Benin in 1985 to that in 1989?
Give a very brief answer. 0.91. What is the ratio of the Value added (current US$) in Japan in 1985 to that in 1989?
Give a very brief answer. 0.46. What is the ratio of the Value added (current US$) of Heavily indebted poor countries in 1985 to that in 1990?
Give a very brief answer. 0.78. What is the ratio of the Value added (current US$) in Latin America(all income levels) in 1985 to that in 1990?
Your answer should be very brief. 0.72. What is the ratio of the Value added (current US$) in Benin in 1985 to that in 1990?
Provide a short and direct response. 0.72. What is the ratio of the Value added (current US$) in Japan in 1985 to that in 1990?
Offer a terse response. 0.45. What is the ratio of the Value added (current US$) in Heavily indebted poor countries in 1986 to that in 1987?
Provide a succinct answer. 0.91. What is the ratio of the Value added (current US$) in Latin America(all income levels) in 1986 to that in 1987?
Your response must be concise. 0.94. What is the ratio of the Value added (current US$) of Benin in 1986 to that in 1987?
Offer a terse response. 0.84. What is the ratio of the Value added (current US$) in Japan in 1986 to that in 1987?
Ensure brevity in your answer.  0.83. What is the ratio of the Value added (current US$) of Heavily indebted poor countries in 1986 to that in 1988?
Keep it short and to the point. 0.9. What is the ratio of the Value added (current US$) of Latin America(all income levels) in 1986 to that in 1988?
Offer a very short reply. 0.84. What is the ratio of the Value added (current US$) in Benin in 1986 to that in 1988?
Keep it short and to the point. 0.75. What is the ratio of the Value added (current US$) of Japan in 1986 to that in 1988?
Give a very brief answer. 0.68. What is the ratio of the Value added (current US$) of Heavily indebted poor countries in 1986 to that in 1989?
Give a very brief answer. 0.88. What is the ratio of the Value added (current US$) of Latin America(all income levels) in 1986 to that in 1989?
Your response must be concise. 0.75. What is the ratio of the Value added (current US$) in Benin in 1986 to that in 1989?
Your answer should be very brief. 0.84. What is the ratio of the Value added (current US$) of Japan in 1986 to that in 1989?
Ensure brevity in your answer.  0.68. What is the ratio of the Value added (current US$) of Heavily indebted poor countries in 1986 to that in 1990?
Your response must be concise. 0.85. What is the ratio of the Value added (current US$) in Latin America(all income levels) in 1986 to that in 1990?
Keep it short and to the point. 0.74. What is the ratio of the Value added (current US$) of Benin in 1986 to that in 1990?
Your response must be concise. 0.66. What is the ratio of the Value added (current US$) in Japan in 1986 to that in 1990?
Offer a terse response. 0.65. What is the ratio of the Value added (current US$) of Heavily indebted poor countries in 1987 to that in 1988?
Ensure brevity in your answer.  0.99. What is the ratio of the Value added (current US$) in Latin America(all income levels) in 1987 to that in 1988?
Your answer should be very brief. 0.89. What is the ratio of the Value added (current US$) in Benin in 1987 to that in 1988?
Offer a terse response. 0.89. What is the ratio of the Value added (current US$) in Japan in 1987 to that in 1988?
Give a very brief answer. 0.82. What is the ratio of the Value added (current US$) of Heavily indebted poor countries in 1987 to that in 1989?
Provide a short and direct response. 0.97. What is the ratio of the Value added (current US$) of Latin America(all income levels) in 1987 to that in 1989?
Provide a short and direct response. 0.8. What is the ratio of the Value added (current US$) of Benin in 1987 to that in 1989?
Offer a terse response. 1.01. What is the ratio of the Value added (current US$) in Japan in 1987 to that in 1989?
Provide a succinct answer. 0.82. What is the ratio of the Value added (current US$) of Heavily indebted poor countries in 1987 to that in 1990?
Offer a very short reply. 0.93. What is the ratio of the Value added (current US$) in Latin America(all income levels) in 1987 to that in 1990?
Make the answer very short. 0.78. What is the ratio of the Value added (current US$) of Benin in 1987 to that in 1990?
Your answer should be very brief. 0.79. What is the ratio of the Value added (current US$) in Japan in 1987 to that in 1990?
Offer a very short reply. 0.79. What is the ratio of the Value added (current US$) of Heavily indebted poor countries in 1988 to that in 1989?
Keep it short and to the point. 0.98. What is the ratio of the Value added (current US$) in Latin America(all income levels) in 1988 to that in 1989?
Provide a short and direct response. 0.9. What is the ratio of the Value added (current US$) of Benin in 1988 to that in 1989?
Make the answer very short. 1.13. What is the ratio of the Value added (current US$) of Heavily indebted poor countries in 1988 to that in 1990?
Make the answer very short. 0.95. What is the ratio of the Value added (current US$) of Latin America(all income levels) in 1988 to that in 1990?
Your answer should be compact. 0.88. What is the ratio of the Value added (current US$) of Benin in 1988 to that in 1990?
Give a very brief answer. 0.89. What is the ratio of the Value added (current US$) in Japan in 1988 to that in 1990?
Your answer should be very brief. 0.97. What is the ratio of the Value added (current US$) in Heavily indebted poor countries in 1989 to that in 1990?
Make the answer very short. 0.97. What is the ratio of the Value added (current US$) in Latin America(all income levels) in 1989 to that in 1990?
Give a very brief answer. 0.98. What is the ratio of the Value added (current US$) of Benin in 1989 to that in 1990?
Ensure brevity in your answer.  0.79. What is the ratio of the Value added (current US$) of Japan in 1989 to that in 1990?
Provide a succinct answer. 0.97. What is the difference between the highest and the second highest Value added (current US$) in Heavily indebted poor countries?
Provide a short and direct response. 1.01e+09. What is the difference between the highest and the second highest Value added (current US$) of Latin America(all income levels)?
Your answer should be compact. 8.32e+09. What is the difference between the highest and the second highest Value added (current US$) in Benin?
Offer a very short reply. 2.71e+07. What is the difference between the highest and the second highest Value added (current US$) of Japan?
Offer a terse response. 3.95e+1. What is the difference between the highest and the lowest Value added (current US$) of Heavily indebted poor countries?
Make the answer very short. 6.90e+09. What is the difference between the highest and the lowest Value added (current US$) in Latin America(all income levels)?
Provide a succinct answer. 1.17e+11. What is the difference between the highest and the lowest Value added (current US$) of Benin?
Your answer should be compact. 8.23e+07. What is the difference between the highest and the lowest Value added (current US$) of Japan?
Keep it short and to the point. 6.74e+11. 